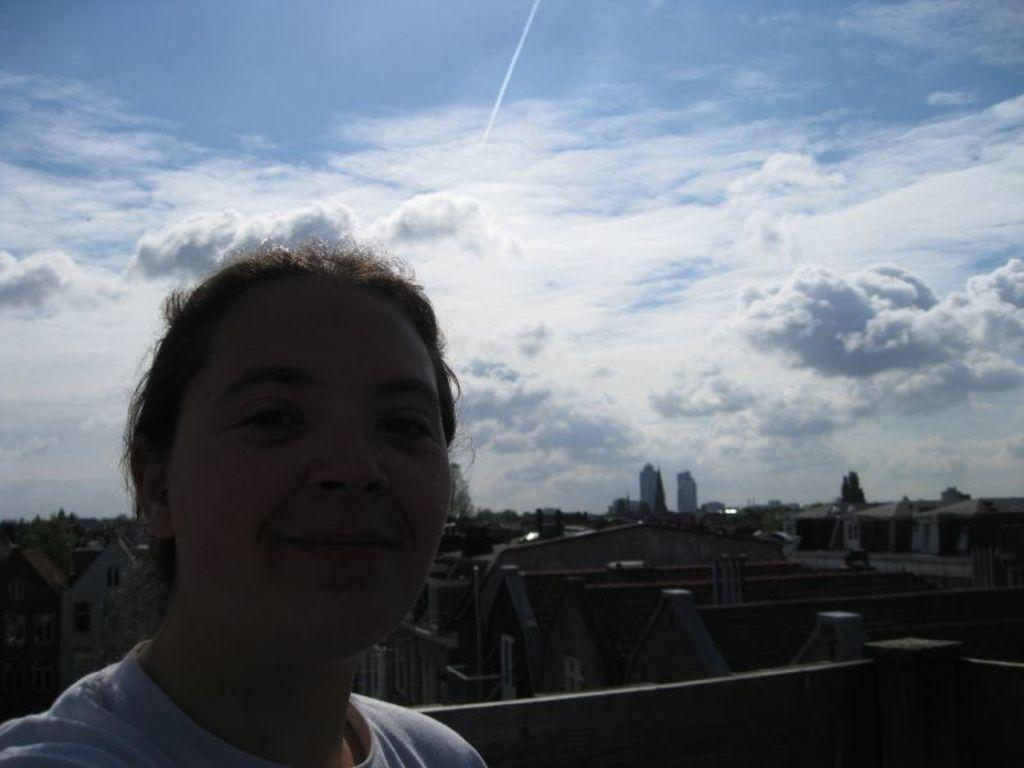Who is present in the image? There is a person in the image. What is the person wearing? The person is wearing a white T-shirt. What can be seen in the background of the image? There are houses in the background of the image. What is the color of the sky in the image? The sky is blue in the image. Are there any weather conditions visible in the image? Yes, there are clouds in the sky. What type of animal is the person working with in the image? There is no animal present in the image, and the person is not depicted as working with any animal. What level of education does the person in the image have? There is no information about the person's education level in the image. 